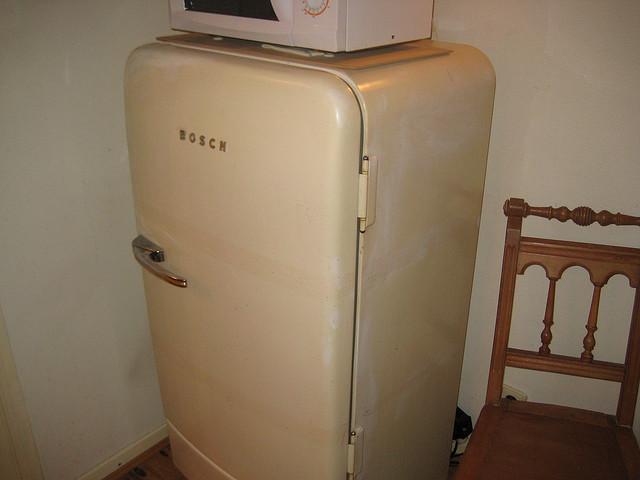How many people have remotes in their hands?
Give a very brief answer. 0. 